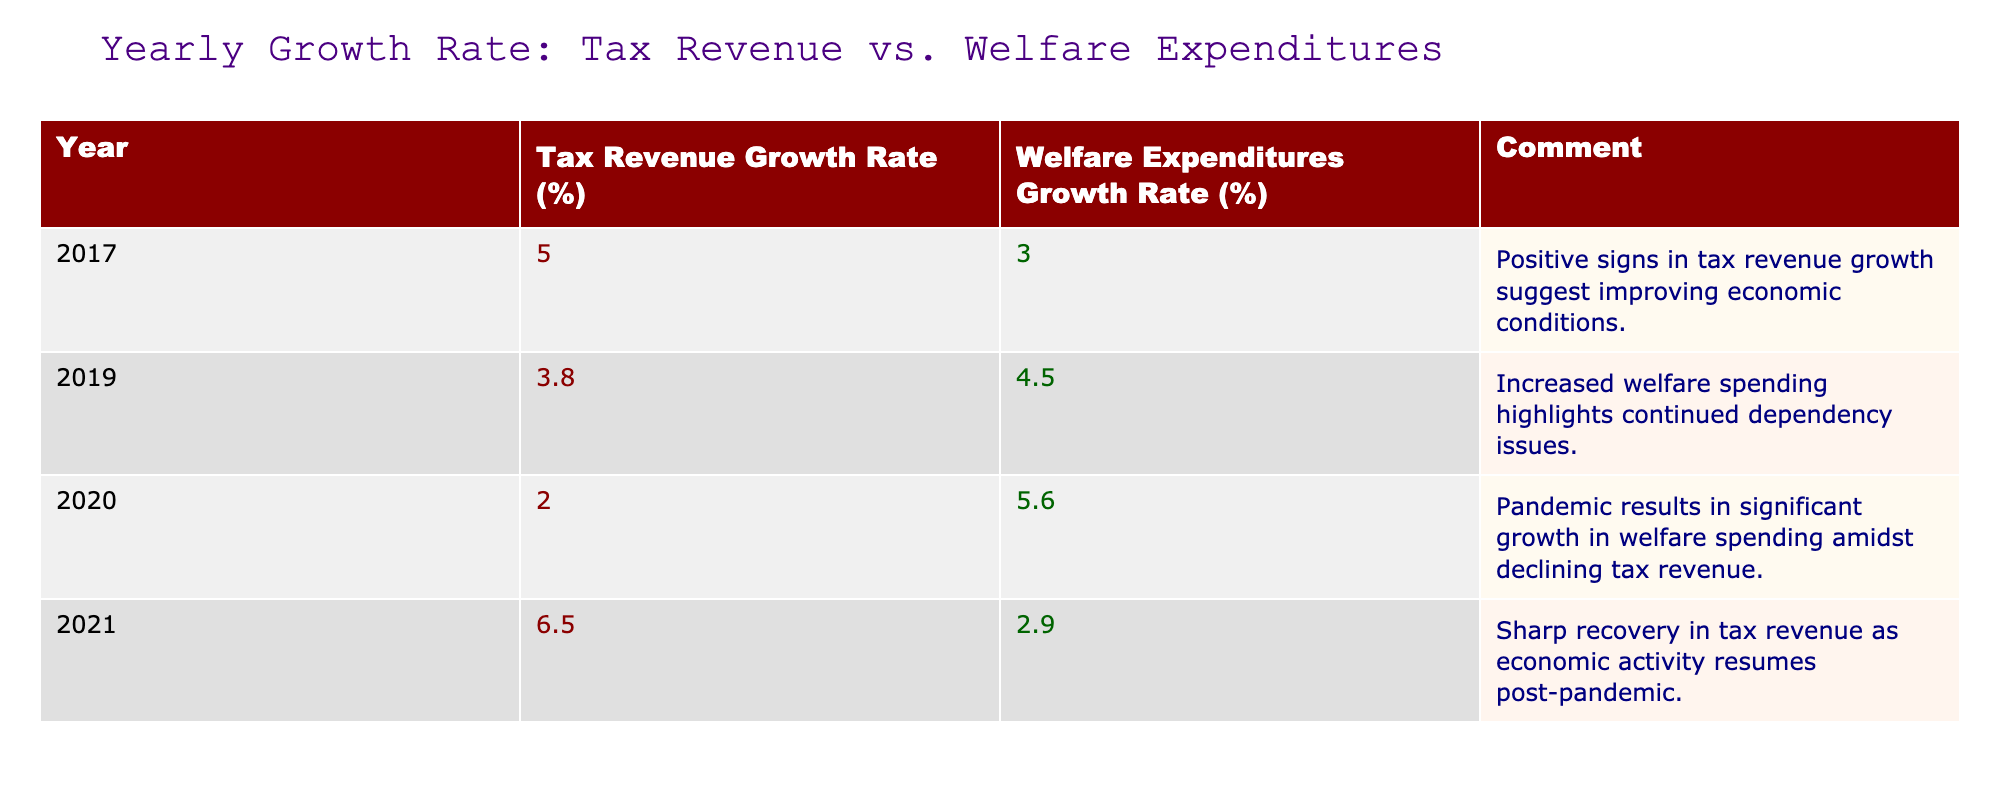What was the tax revenue growth rate in 2019? The table indicates that the tax revenue growth rate in 2019 is 3.8%.
Answer: 3.8% In which year did welfare expenditures experience the highest growth rate? According to the table, the highest growth rate for welfare expenditures is 5.6% in 2020.
Answer: 2020 What is the difference between the tax revenue growth rate in 2021 and that in 2017? In 2021, the tax revenue growth rate is 6.5%, and in 2017, it is 5.0%. The difference is 6.5% - 5.0% = 1.5%.
Answer: 1.5% What year had the lowest tax revenue growth rate? The lowest tax revenue growth rate is during 2020 with a rate of 2.0%, as indicated in the table.
Answer: 2020 Is it true that the tax revenue growth rate always exceeded the welfare expenditures growth rate from 2015 to 2022? No, it is not true. In 2020, the welfare expenditures growth rate (5.6%) exceeded the tax revenue growth rate (2.0%).
Answer: No What was the average growth rate of tax revenue from 2017 to 2021? The tax revenue growth rates for 2017, 2019, and 2021 are 5.0%, 3.8%, and 6.5%, respectively. The average can be calculated as (5.0 + 3.8 + 6.5) / 3 = 5.17%.
Answer: 5.17% Which year saw a recovery in tax revenue growth to its highest level after the pandemic? Following the pandemic, the highest tax revenue growth rate was 6.5% in 2021, indicating a recovery.
Answer: 2021 Was the growth rate of welfare expenditures lower in 2021 compared to 2020? Yes, the welfare expenditures growth rate decreased from 5.6% in 2020 to 2.9% in 2021.
Answer: Yes How much did the tax revenue growth rate increase from 2020 to 2021? The tax revenue growth rate in 2020 is 2.0%, and in 2021 it is 6.5%. The increase is 6.5% - 2.0% = 4.5%.
Answer: 4.5% Which year shows a significant contrast between the growth rates of tax revenue and welfare expenditures? The year 2020 shows a significant contrast, with tax revenue growth at 2.0% and welfare expenditures growth at 5.6%.
Answer: 2020 